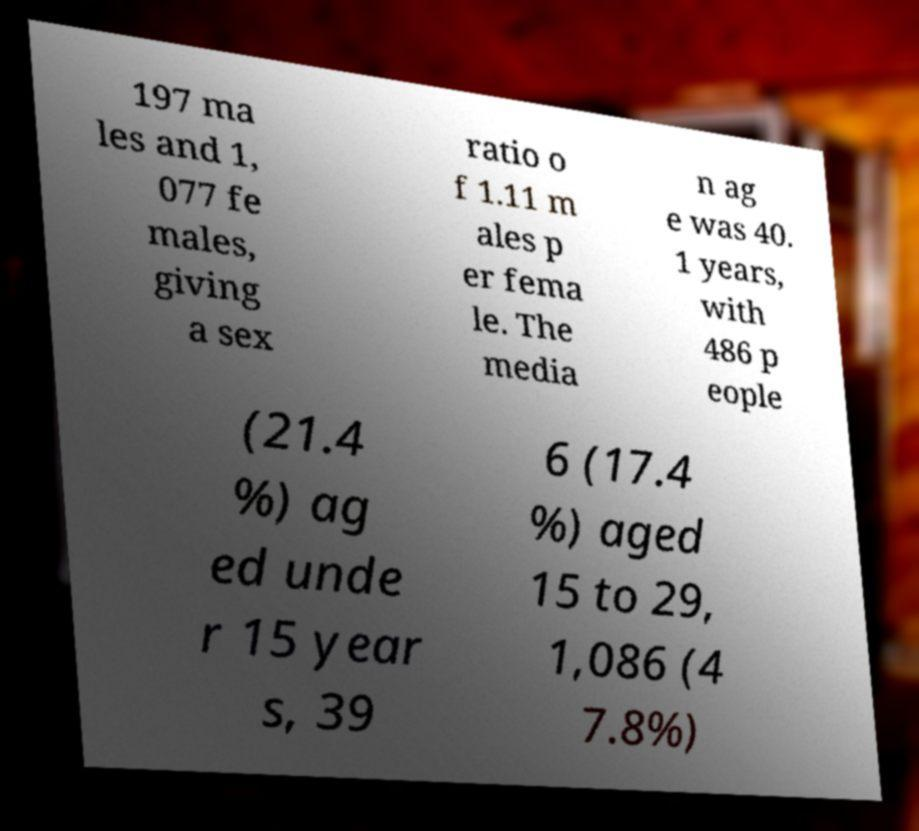What messages or text are displayed in this image? I need them in a readable, typed format. 197 ma les and 1, 077 fe males, giving a sex ratio o f 1.11 m ales p er fema le. The media n ag e was 40. 1 years, with 486 p eople (21.4 %) ag ed unde r 15 year s, 39 6 (17.4 %) aged 15 to 29, 1,086 (4 7.8%) 